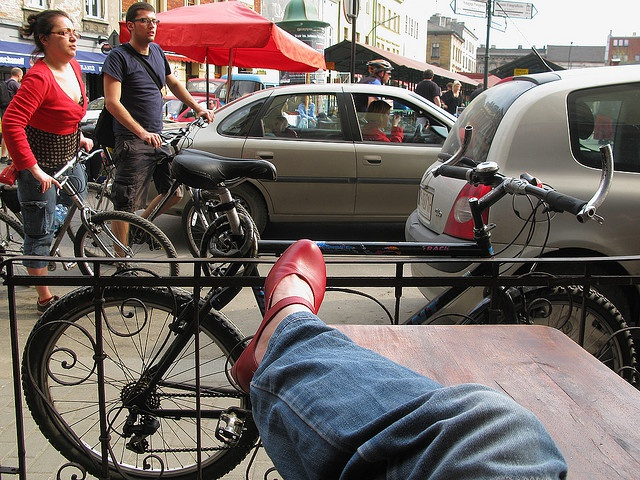Describe the objects in this image and their specific colors. I can see bicycle in ivory, black, darkgray, and gray tones, car in ivory, gray, black, darkgray, and lightgray tones, car in ivory, black, and gray tones, people in ivory, black, and gray tones, and dining table in ivory, darkgray, and lightgray tones in this image. 